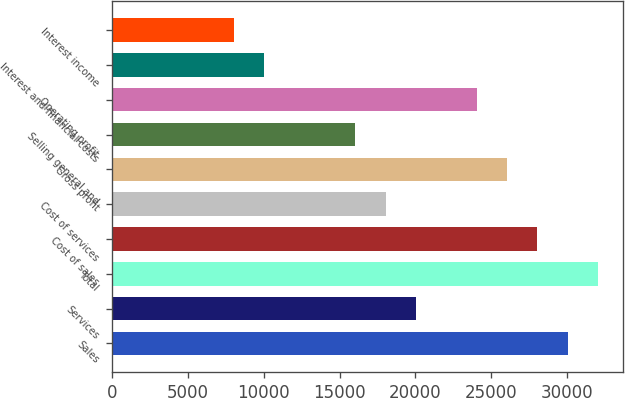Convert chart to OTSL. <chart><loc_0><loc_0><loc_500><loc_500><bar_chart><fcel>Sales<fcel>Services<fcel>Total<fcel>Cost of sales<fcel>Cost of services<fcel>Gross profit<fcel>Selling general and<fcel>Operating profit<fcel>Interest and financial costs<fcel>Interest income<nl><fcel>30061.2<fcel>20041<fcel>32065.3<fcel>28057.2<fcel>18036.9<fcel>26053.1<fcel>16032.9<fcel>24049.1<fcel>10020.7<fcel>8016.69<nl></chart> 